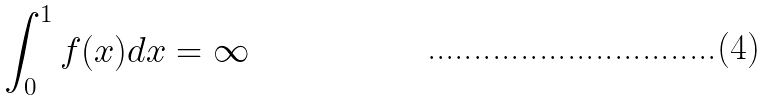<formula> <loc_0><loc_0><loc_500><loc_500>\int _ { 0 } ^ { 1 } f ( x ) d x = \infty</formula> 